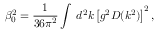<formula> <loc_0><loc_0><loc_500><loc_500>\beta _ { 0 } ^ { 2 } = \frac { 1 } { 3 6 \pi ^ { 2 } } \int \, d ^ { 2 } k \left [ g ^ { 2 } D ( k ^ { 2 } ) \right ] ^ { 2 } ,</formula> 